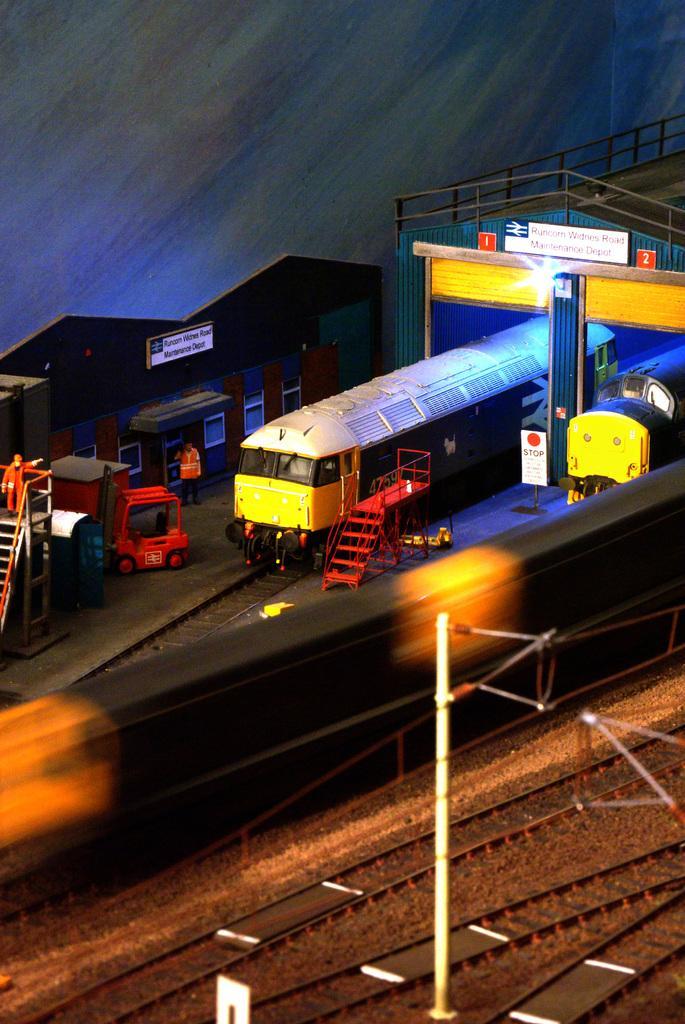Please provide a concise description of this image. In this picture we can observe toys. There is an engine on the railway track. We can observe railway station. There are some railway tracks and a white color pole. We can observe some vehicles here. In the background it is completely blur. All of these were toys. 